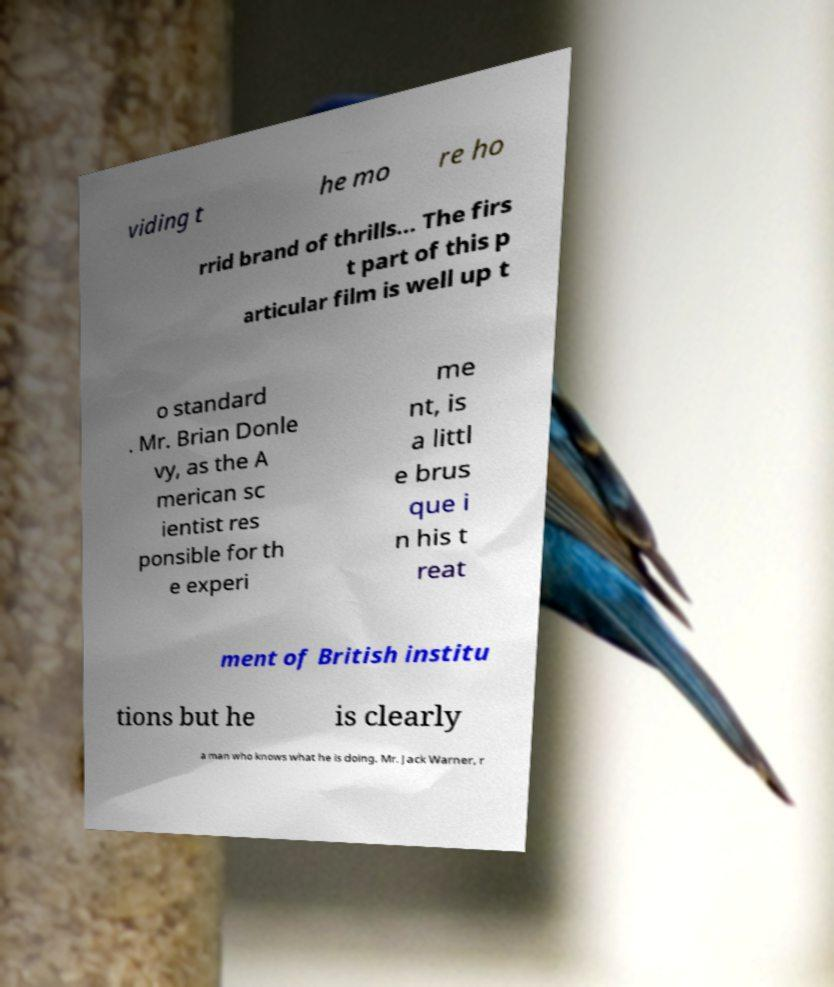Please read and relay the text visible in this image. What does it say? viding t he mo re ho rrid brand of thrills... The firs t part of this p articular film is well up t o standard . Mr. Brian Donle vy, as the A merican sc ientist res ponsible for th e experi me nt, is a littl e brus que i n his t reat ment of British institu tions but he is clearly a man who knows what he is doing. Mr. Jack Warner, r 